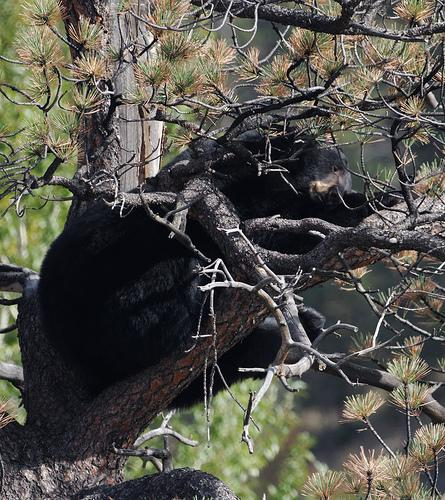Describe the visual elements and textures present in the image. A black bear with textured fur rests on a rough bark-covered tree branch, surrounded by vibrant green pine needles, leaves, and curvy branches. Write a brief headline to summarize the image. Black Bear Rests Amidst Pine Needles and Tree Branches Provide a brief overview of the image content. A black bear is resting on a tree branch, surrounded by pine needles and bark, with its brown muzzle and eyes visible. Mention the main subject of the image and its relation to the environment. A black bear is laying on a tree branch, seamlessly blending into its natural surroundings of bark, green pine needles, and leaves. In a simple sentence, describe the main subject and its action in the image. A black bear is lying on a tree branch, surrounded by green pine needles and leaves. Mention the central focus of the image and its details in a descriptive way. A beautiful black bear is peacefully relaxing on a sturdy tree branch, surrounded by lush green pine needles and an array of leaves and branches. Describe the environment surrounding the main subject of the image. The black bear is resting on a tree branch amidst pine needles, green leaves, and curvy branches, with a blurry green backdrop. Provide a poetic description of the image. In the arms of a mighty tree, a majestic black bear finds solace, cradled by verdant leaves and the gentle whispers of pine needles. Describe the primary animal and its position in the image. A black bear with a brown muzzle is laying on a tree branch, surrounded by green leaves and branches. Point out the main elements of the photograph that involve nature. A black bear is resting on a bark-covered tree branch, surrounded by green pine needles and leaves on curvy branches. 